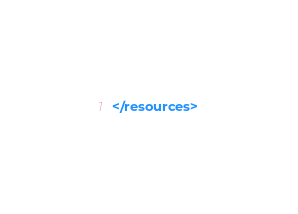<code> <loc_0><loc_0><loc_500><loc_500><_XML_></resources>
</code> 